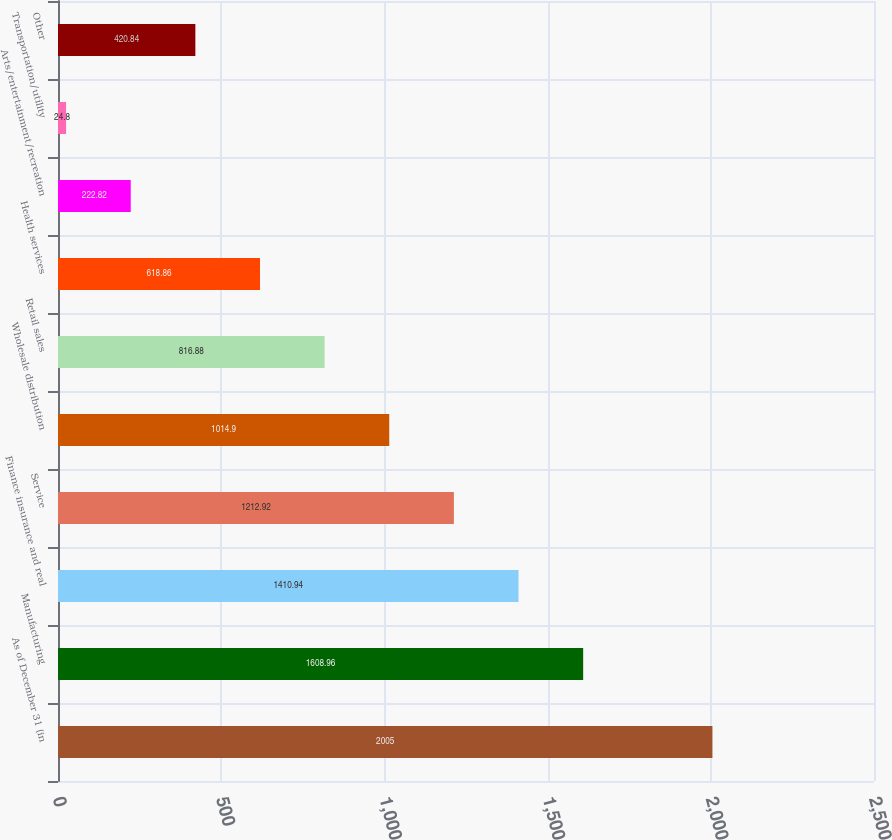Convert chart to OTSL. <chart><loc_0><loc_0><loc_500><loc_500><bar_chart><fcel>As of December 31 (in<fcel>Manufacturing<fcel>Finance insurance and real<fcel>Service<fcel>Wholesale distribution<fcel>Retail sales<fcel>Health services<fcel>Arts/entertainment/recreation<fcel>Transportation/utility<fcel>Other<nl><fcel>2005<fcel>1608.96<fcel>1410.94<fcel>1212.92<fcel>1014.9<fcel>816.88<fcel>618.86<fcel>222.82<fcel>24.8<fcel>420.84<nl></chart> 